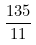Convert formula to latex. <formula><loc_0><loc_0><loc_500><loc_500>\frac { 1 3 5 } { 1 1 }</formula> 